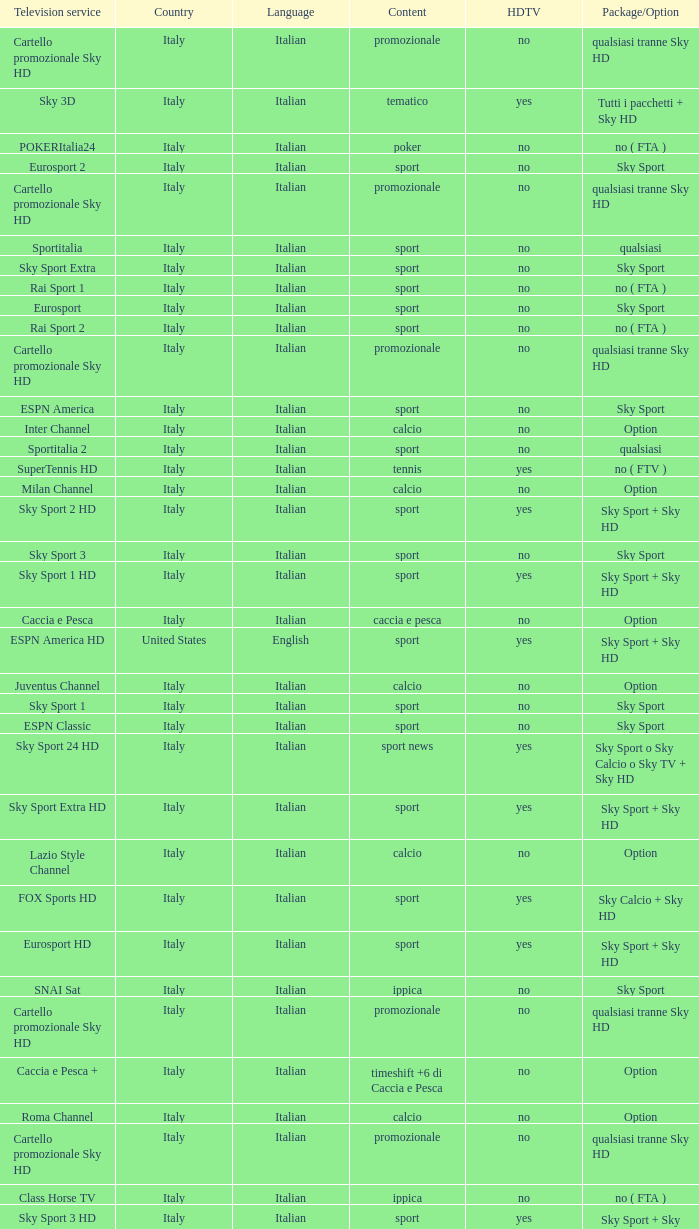What is Language, when Content is Sport, when HDTV is No, and when Television Service is ESPN America? Italian. 